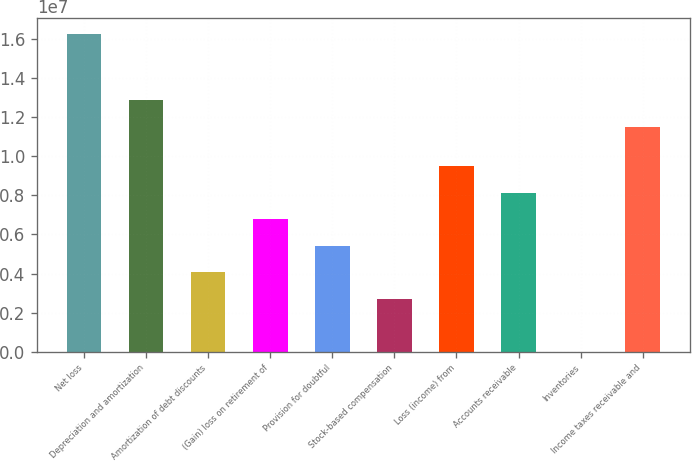Convert chart to OTSL. <chart><loc_0><loc_0><loc_500><loc_500><bar_chart><fcel>Net loss<fcel>Depreciation and amortization<fcel>Amortization of debt discounts<fcel>(Gain) loss on retirement of<fcel>Provision for doubtful<fcel>Stock-based compensation<fcel>Loss (income) from<fcel>Accounts receivable<fcel>Inventories<fcel>Income taxes receivable and<nl><fcel>1.62424e+07<fcel>1.28599e+07<fcel>4.06552e+06<fcel>6.77149e+06<fcel>5.41851e+06<fcel>2.71254e+06<fcel>9.47746e+06<fcel>8.12448e+06<fcel>6571<fcel>1.15069e+07<nl></chart> 